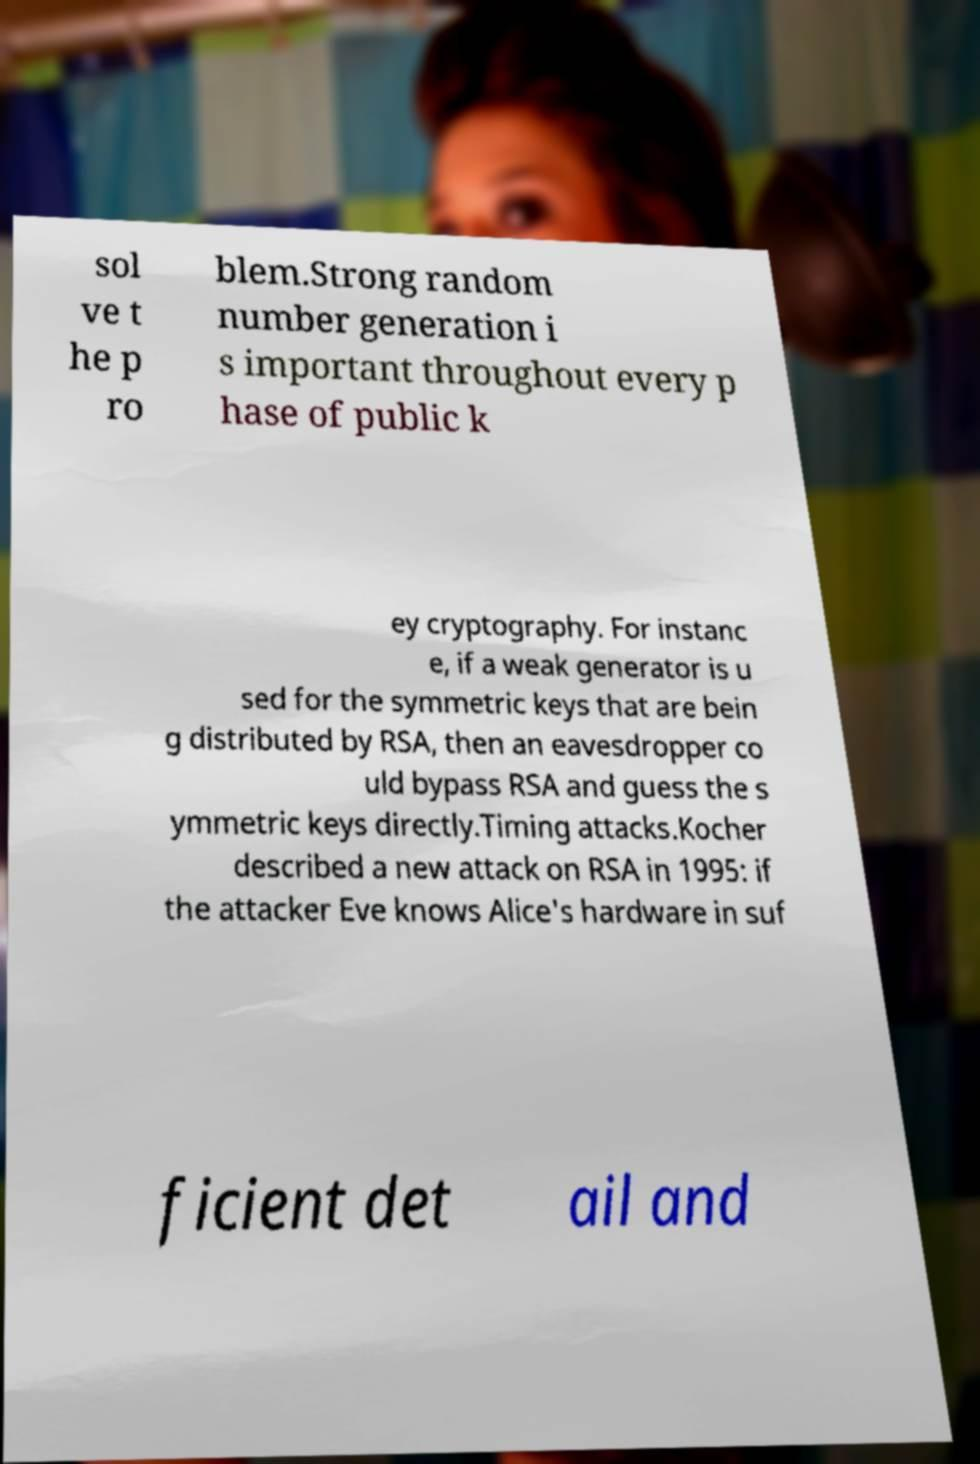Can you accurately transcribe the text from the provided image for me? sol ve t he p ro blem.Strong random number generation i s important throughout every p hase of public k ey cryptography. For instanc e, if a weak generator is u sed for the symmetric keys that are bein g distributed by RSA, then an eavesdropper co uld bypass RSA and guess the s ymmetric keys directly.Timing attacks.Kocher described a new attack on RSA in 1995: if the attacker Eve knows Alice's hardware in suf ficient det ail and 